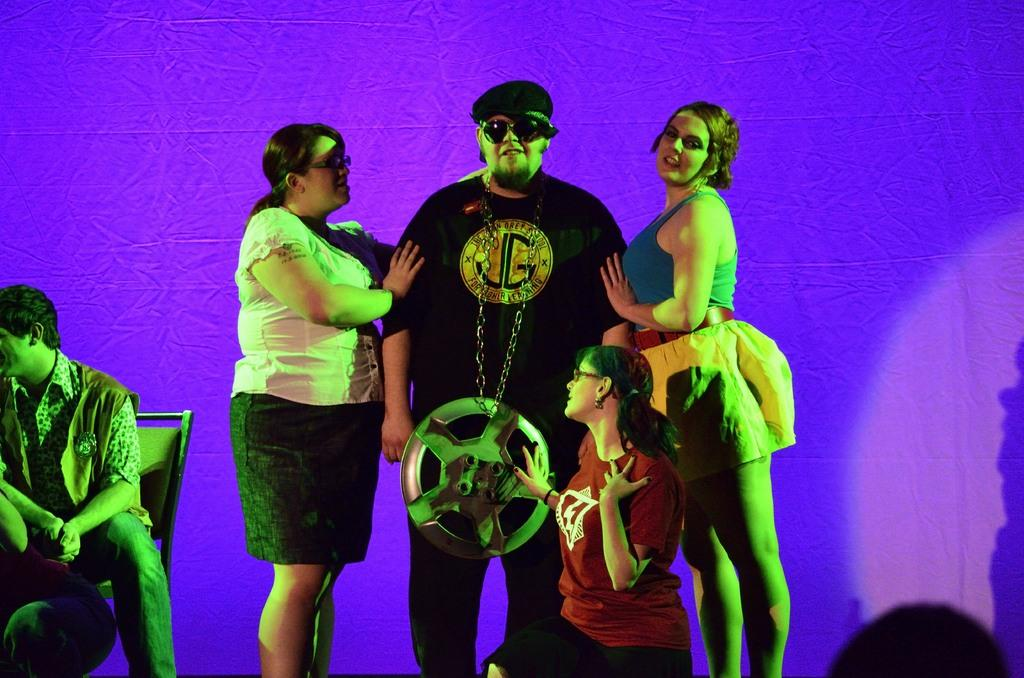How many people are present in the image? There are three people standing in the image. What is the person at the center wearing on their head? The person at the center is wearing a cap. What is the person at the center wearing to protect their eyes? The person at the center is wearing goggles. What type of accessory is the person at the center wearing around their neck? The person at the center is wearing a long chain. Where is the person sitting in the image? There is a person sitting on a chair at the left side of the image. How many toes can be seen on the person sitting on the chair? There is no visible toes on the person sitting on the chair in the image. What type of tray is being used by the crowd in the image? There is no crowd present in the image, and therefore no tray can be observed. 